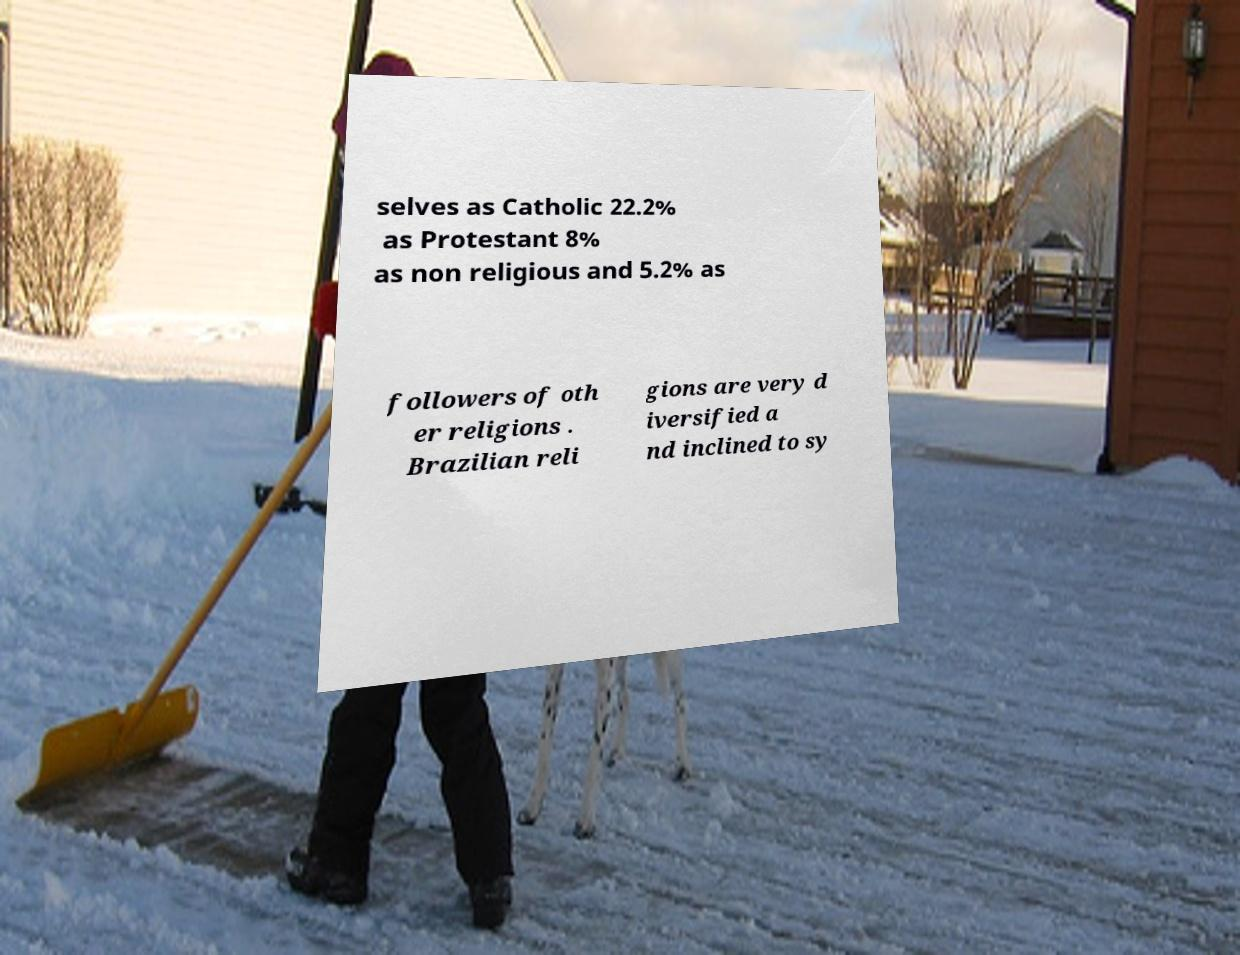Could you extract and type out the text from this image? selves as Catholic 22.2% as Protestant 8% as non religious and 5.2% as followers of oth er religions . Brazilian reli gions are very d iversified a nd inclined to sy 